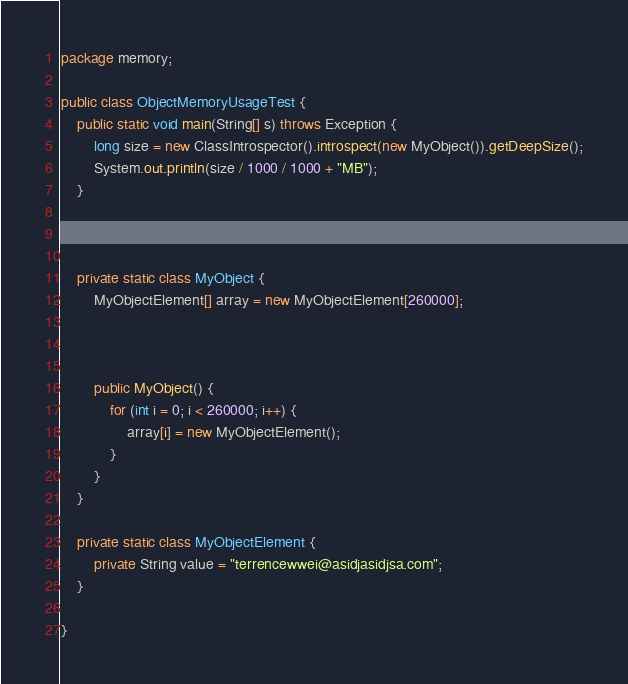Convert code to text. <code><loc_0><loc_0><loc_500><loc_500><_Java_>package memory;

public class ObjectMemoryUsageTest {
    public static void main(String[] s) throws Exception {
        long size = new ClassIntrospector().introspect(new MyObject()).getDeepSize();
        System.out.println(size / 1000 / 1000 + "MB");
    }



    private static class MyObject {
        MyObjectElement[] array = new MyObjectElement[260000];



        public MyObject() {
            for (int i = 0; i < 260000; i++) {
                array[i] = new MyObjectElement();
            }
        }
    }

    private static class MyObjectElement {
        private String value = "terrencewwei@asidjasidjsa.com";
    }

}

</code> 